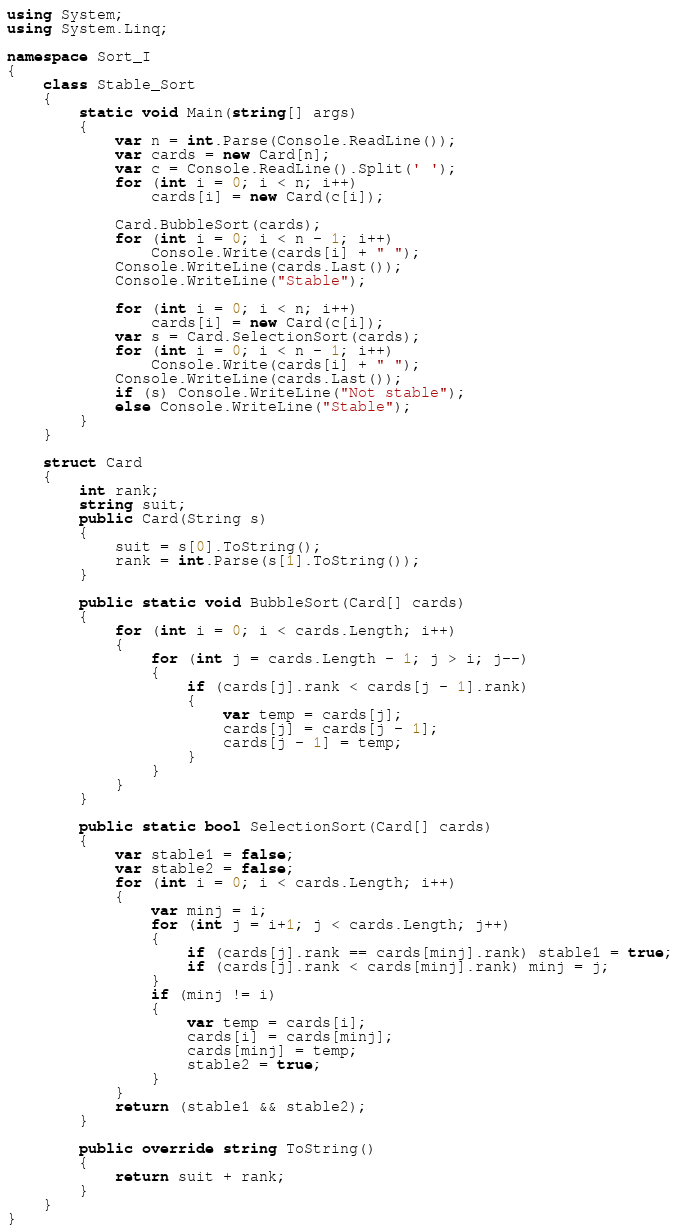Convert code to text. <code><loc_0><loc_0><loc_500><loc_500><_C#_>using System;
using System.Linq;

namespace Sort_I
{
    class Stable_Sort
    {
        static void Main(string[] args)
        {
            var n = int.Parse(Console.ReadLine());
            var cards = new Card[n];
            var c = Console.ReadLine().Split(' ');
            for (int i = 0; i < n; i++)
                cards[i] = new Card(c[i]);

            Card.BubbleSort(cards);
            for (int i = 0; i < n - 1; i++)
                Console.Write(cards[i] + " ");
            Console.WriteLine(cards.Last());
            Console.WriteLine("Stable");

            for (int i = 0; i < n; i++)
                cards[i] = new Card(c[i]);
            var s = Card.SelectionSort(cards);
            for (int i = 0; i < n - 1; i++)
                Console.Write(cards[i] + " ");
            Console.WriteLine(cards.Last());
            if (s) Console.WriteLine("Not stable");
            else Console.WriteLine("Stable");
        }
    }

    struct Card
    {
        int rank;
        string suit;
        public Card(String s)
        {
            suit = s[0].ToString();
            rank = int.Parse(s[1].ToString());
        }

        public static void BubbleSort(Card[] cards)
        {
            for (int i = 0; i < cards.Length; i++)
            {
                for (int j = cards.Length - 1; j > i; j--)
                {
                    if (cards[j].rank < cards[j - 1].rank)
                    {
                        var temp = cards[j];
                        cards[j] = cards[j - 1];
                        cards[j - 1] = temp;
                    }
                }
            }
        }

        public static bool SelectionSort(Card[] cards)
        {
            var stable1 = false;
            var stable2 = false;
            for (int i = 0; i < cards.Length; i++)
            {
                var minj = i;
                for (int j = i+1; j < cards.Length; j++)
                {
                    if (cards[j].rank == cards[minj].rank) stable1 = true;
                    if (cards[j].rank < cards[minj].rank) minj = j;
                }
                if (minj != i)
                {
                    var temp = cards[i];
                    cards[i] = cards[minj];
                    cards[minj] = temp;
                    stable2 = true;
                }
            }
            return (stable1 && stable2);
        }

        public override string ToString()
        {
            return suit + rank;
        }
    }
}</code> 